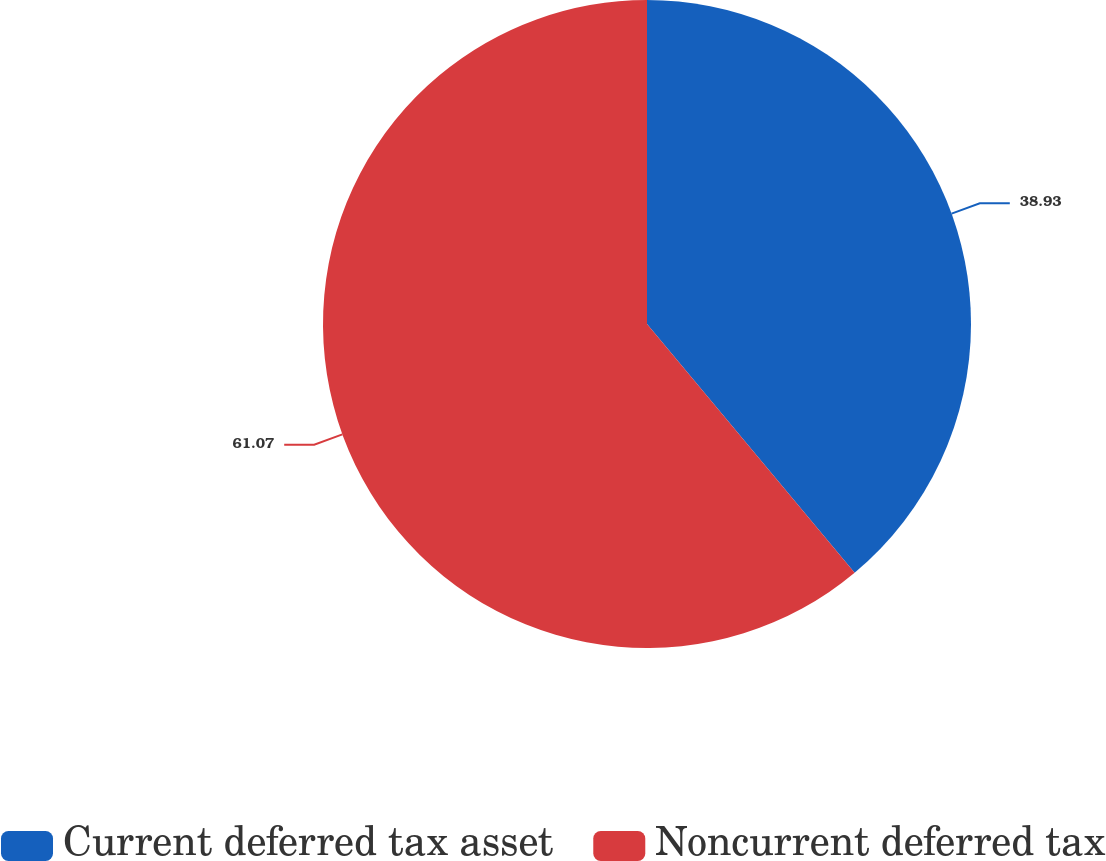<chart> <loc_0><loc_0><loc_500><loc_500><pie_chart><fcel>Current deferred tax asset<fcel>Noncurrent deferred tax<nl><fcel>38.93%<fcel>61.07%<nl></chart> 